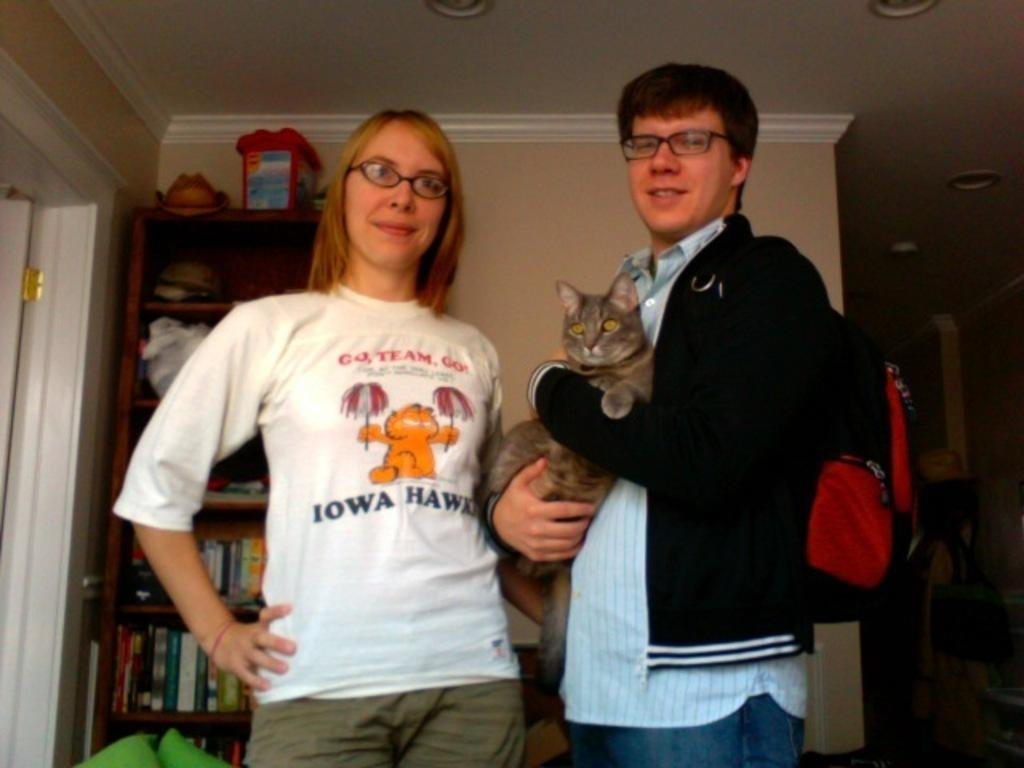What is happening with the people in the image? There are people standing in the image. What is the man holding in his hands? The man is holding a cat in his hands. What accessory is the man wearing? The man is wearing a backpack. What type of objects can be seen in the image? There are books visible in the image. What can be observed on the shelves in the image? There are items on shelves in the image. What type of glass is being crushed under the man's foot in the image? There is no glass present in the image, nor is the man crushing anything under his foot. 